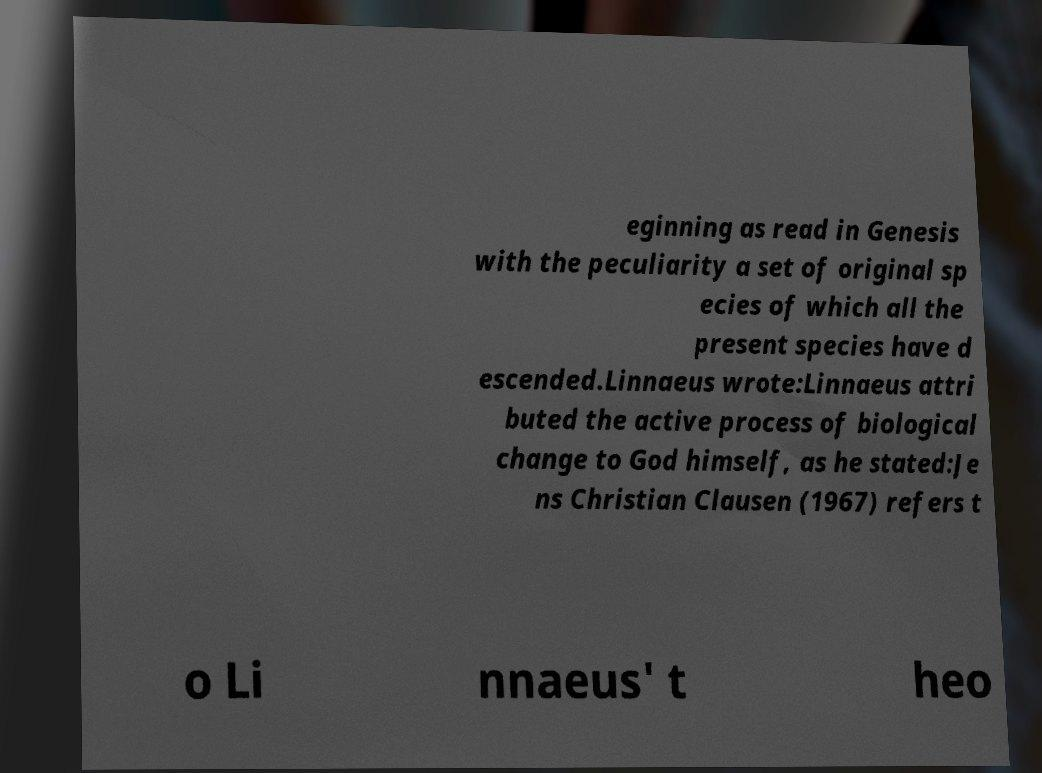Please read and relay the text visible in this image. What does it say? eginning as read in Genesis with the peculiarity a set of original sp ecies of which all the present species have d escended.Linnaeus wrote:Linnaeus attri buted the active process of biological change to God himself, as he stated:Je ns Christian Clausen (1967) refers t o Li nnaeus' t heo 